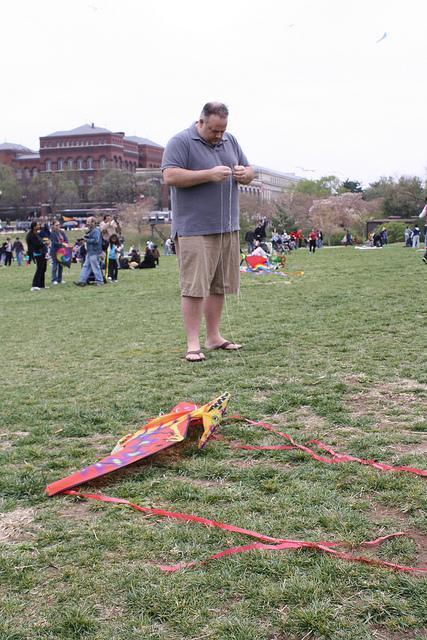How many men are wearing shorts?
Give a very brief answer. 1. How many people can be seen?
Give a very brief answer. 2. 